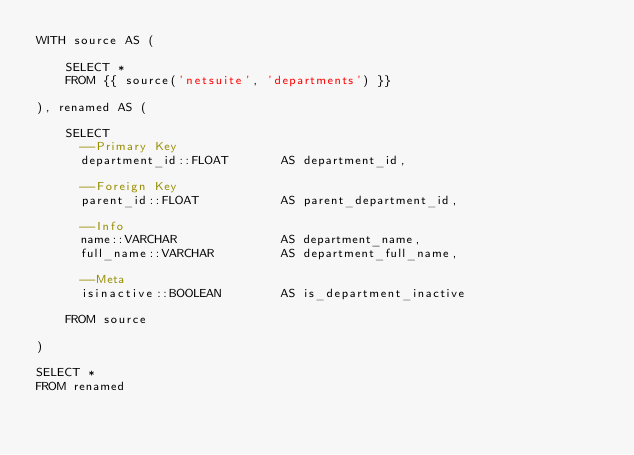<code> <loc_0><loc_0><loc_500><loc_500><_SQL_>WITH source AS (

    SELECT *
    FROM {{ source('netsuite', 'departments') }}

), renamed AS (

    SELECT
      --Primary Key
      department_id::FLOAT       AS department_id,

      --Foreign Key
      parent_id::FLOAT           AS parent_department_id,

      --Info
      name::VARCHAR              AS department_name,
      full_name::VARCHAR         AS department_full_name,

      --Meta
      isinactive::BOOLEAN        AS is_department_inactive

    FROM source

)

SELECT *
FROM renamed
</code> 